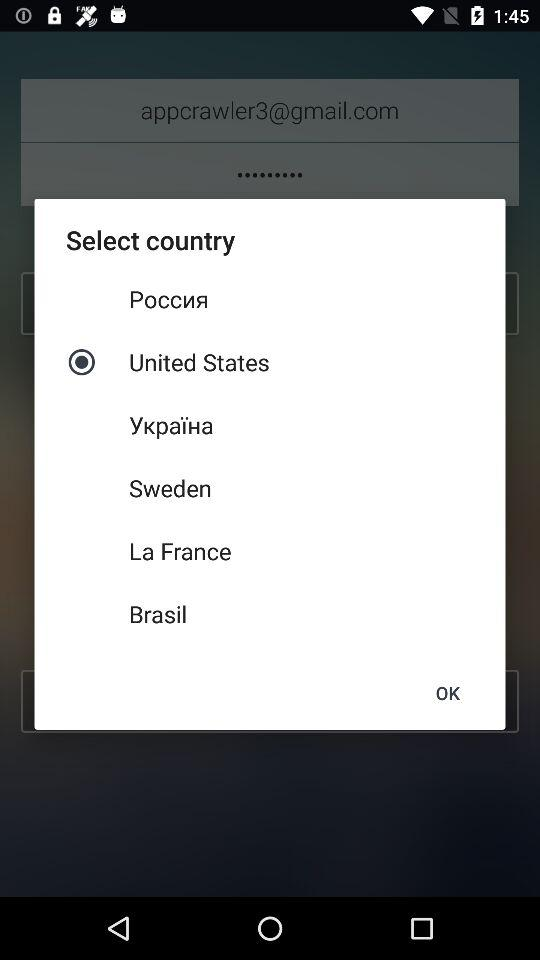How many countries are available to select from?
Answer the question using a single word or phrase. 6 